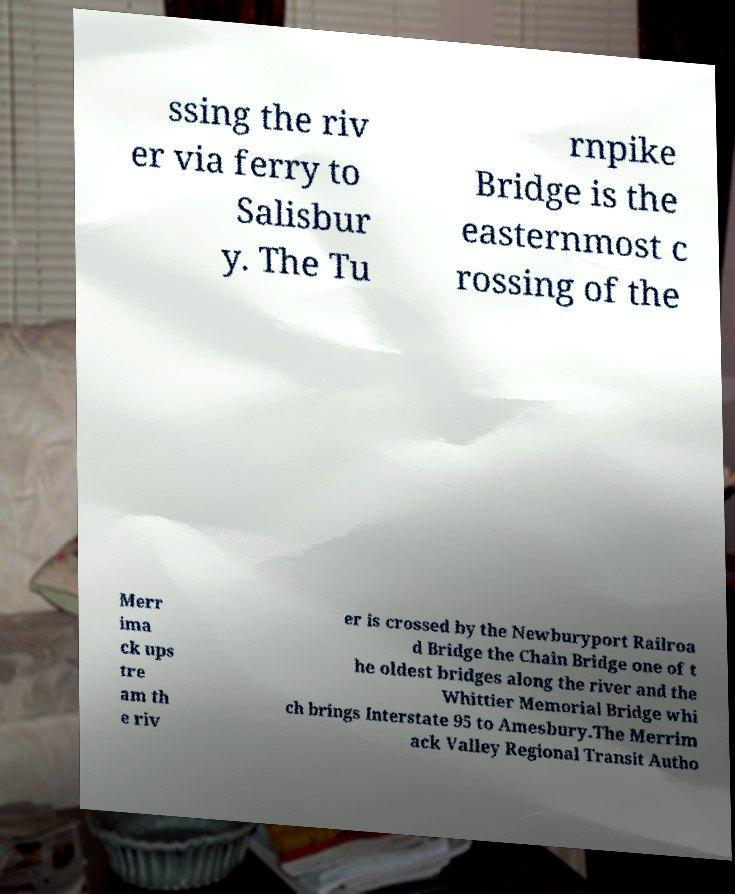Can you accurately transcribe the text from the provided image for me? ssing the riv er via ferry to Salisbur y. The Tu rnpike Bridge is the easternmost c rossing of the Merr ima ck ups tre am th e riv er is crossed by the Newburyport Railroa d Bridge the Chain Bridge one of t he oldest bridges along the river and the Whittier Memorial Bridge whi ch brings Interstate 95 to Amesbury.The Merrim ack Valley Regional Transit Autho 